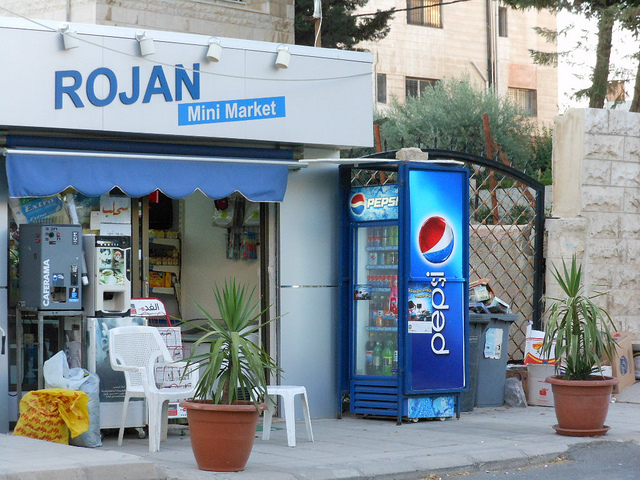What might be the name of the store and how can you tell? The store is named 'ROJAN Mini Market' as indicated by the bold lettering on the blue canopy above the entrance. 